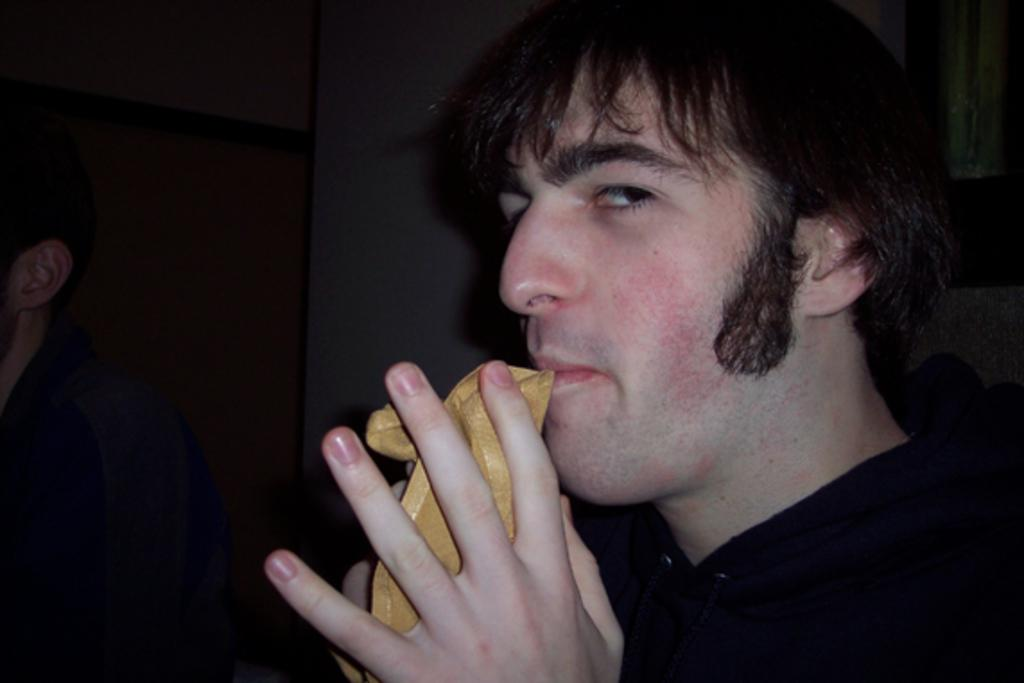Who is present in the image? There is a man in the image. What is the man doing in the image? The man is holding an object. What can be seen in the background of the image? There is a wall in the background of the image. Are there any other people visible in the image? Yes, there is another person in the background of the image. What type of nerve can be seen in the image? There is no nerve present in the image. What kind of meat is being prepared by the man in the image? There is no meat or cooking activity depicted in the image. 